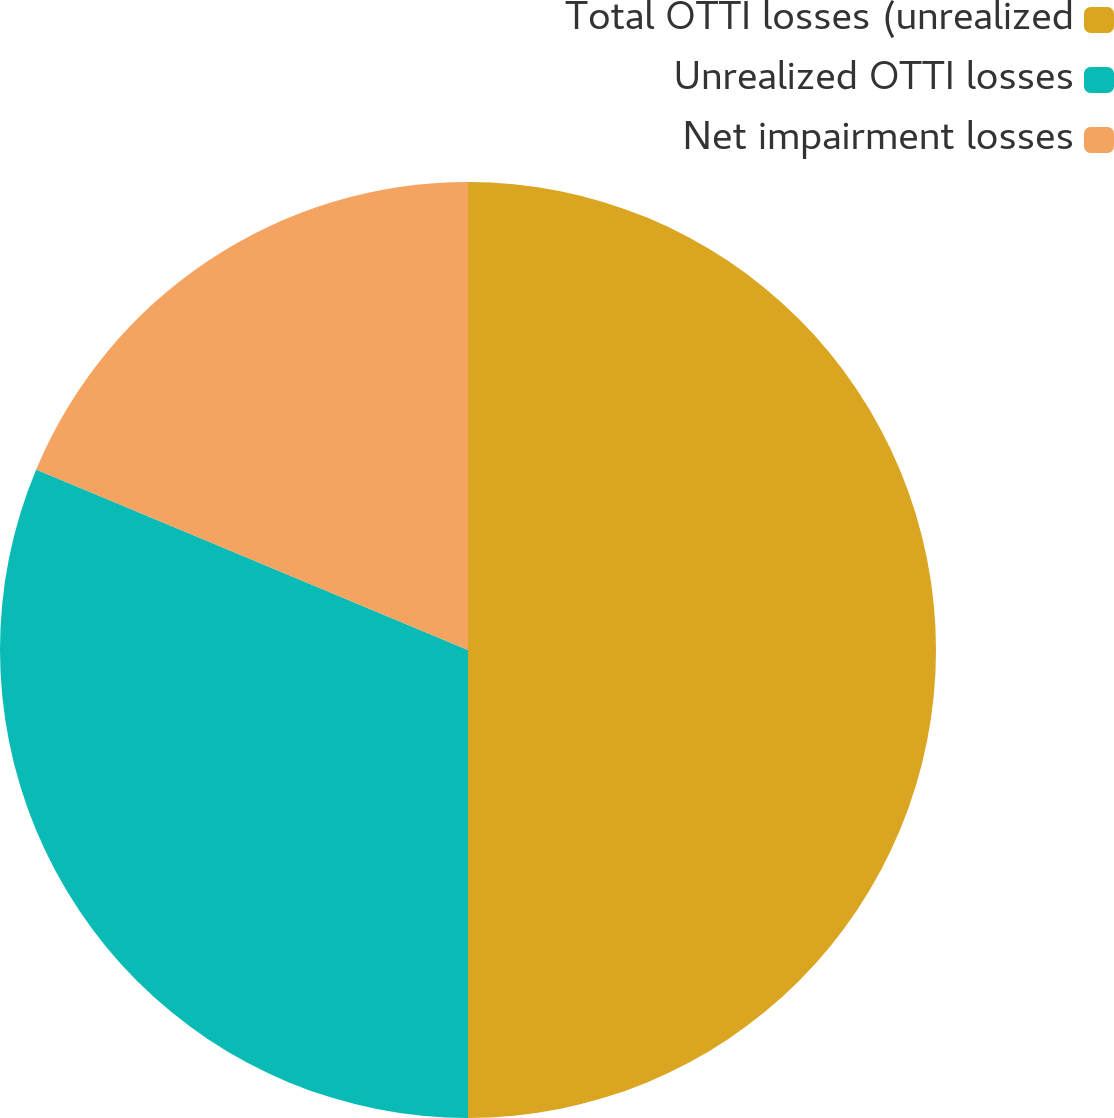Convert chart. <chart><loc_0><loc_0><loc_500><loc_500><pie_chart><fcel>Total OTTI losses (unrealized<fcel>Unrealized OTTI losses<fcel>Net impairment losses<nl><fcel>50.0%<fcel>31.3%<fcel>18.7%<nl></chart> 